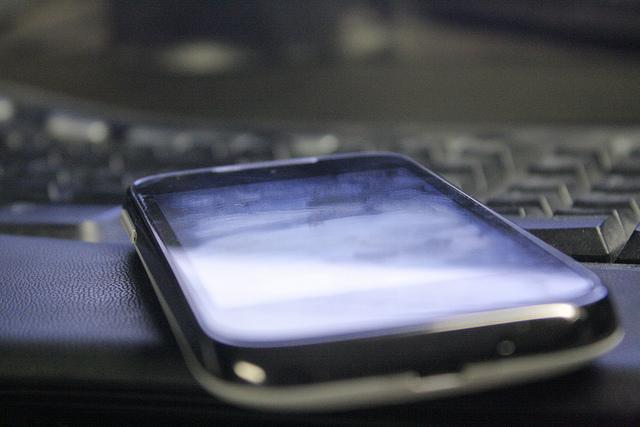Where is the phone sitting?
Give a very brief answer. Keyboard. What style cell phone is shown?
Keep it brief. Smartphone. What type of device is this?
Give a very brief answer. Phone. Can a phone number be dialed on the device shown?
Concise answer only. Yes. 